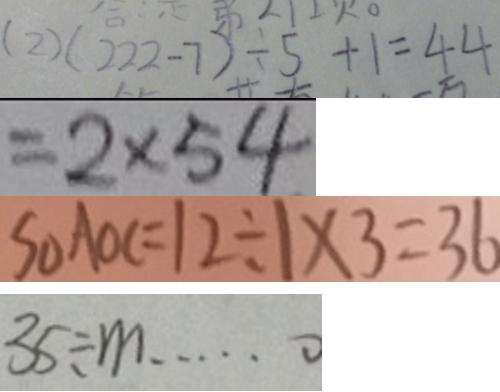Convert formula to latex. <formula><loc_0><loc_0><loc_500><loc_500>( 2 ) ( 2 2 2 - 7 ) \div 5 + 1 = 4 4 
 = 2 \times 5 4 
 S _ { \Delta } A O C = 1 2 \div 1 \times 3 = 3 6 
 3 5 \div m \cdots 0</formula> 